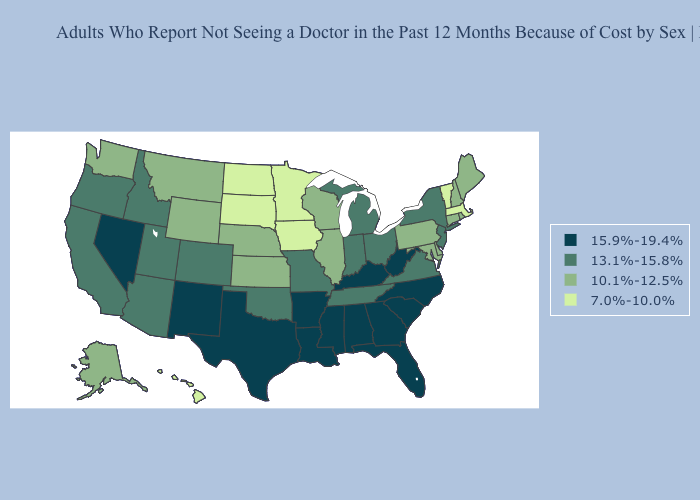Does Wyoming have the lowest value in the USA?
Short answer required. No. What is the value of Nebraska?
Short answer required. 10.1%-12.5%. Does Connecticut have the highest value in the USA?
Answer briefly. No. What is the value of Wyoming?
Write a very short answer. 10.1%-12.5%. Among the states that border Mississippi , which have the lowest value?
Keep it brief. Tennessee. Does the first symbol in the legend represent the smallest category?
Be succinct. No. Among the states that border New Mexico , which have the lowest value?
Keep it brief. Arizona, Colorado, Oklahoma, Utah. Name the states that have a value in the range 10.1%-12.5%?
Short answer required. Alaska, Connecticut, Delaware, Illinois, Kansas, Maine, Maryland, Montana, Nebraska, New Hampshire, Pennsylvania, Rhode Island, Washington, Wisconsin, Wyoming. Name the states that have a value in the range 10.1%-12.5%?
Quick response, please. Alaska, Connecticut, Delaware, Illinois, Kansas, Maine, Maryland, Montana, Nebraska, New Hampshire, Pennsylvania, Rhode Island, Washington, Wisconsin, Wyoming. Does Arkansas have the highest value in the South?
Short answer required. Yes. What is the highest value in states that border South Carolina?
Answer briefly. 15.9%-19.4%. Does the map have missing data?
Answer briefly. No. Name the states that have a value in the range 15.9%-19.4%?
Concise answer only. Alabama, Arkansas, Florida, Georgia, Kentucky, Louisiana, Mississippi, Nevada, New Mexico, North Carolina, South Carolina, Texas, West Virginia. Which states have the highest value in the USA?
Keep it brief. Alabama, Arkansas, Florida, Georgia, Kentucky, Louisiana, Mississippi, Nevada, New Mexico, North Carolina, South Carolina, Texas, West Virginia. What is the highest value in the USA?
Concise answer only. 15.9%-19.4%. 